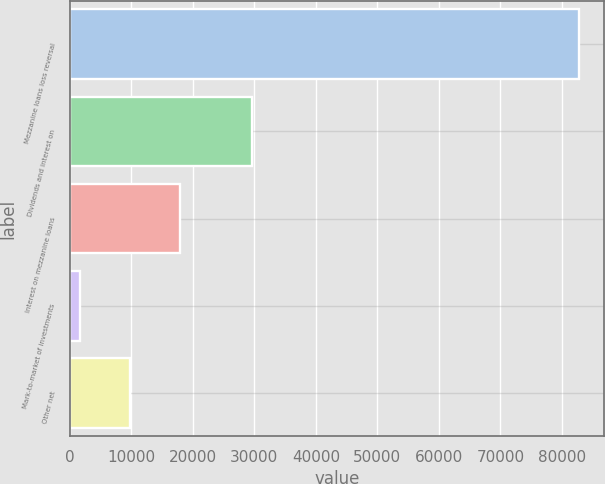<chart> <loc_0><loc_0><loc_500><loc_500><bar_chart><fcel>Mezzanine loans loss reversal<fcel>Dividends and interest on<fcel>Interest on mezzanine loans<fcel>Mark-to-market of investments<fcel>Other net<nl><fcel>82744<fcel>29587<fcel>17875.2<fcel>1658<fcel>9766.6<nl></chart> 